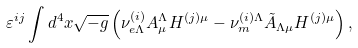<formula> <loc_0><loc_0><loc_500><loc_500>\varepsilon ^ { i j } \int d ^ { 4 } x \sqrt { - g } \left ( { \nu } ^ { ( i ) } _ { e \Lambda } A _ { \mu } ^ { \Lambda } H ^ { ( j ) \mu } - { \nu } ^ { ( i ) \Lambda } _ { m } \tilde { A } _ { \Lambda \mu } H ^ { ( j ) \mu } \right ) ,</formula> 